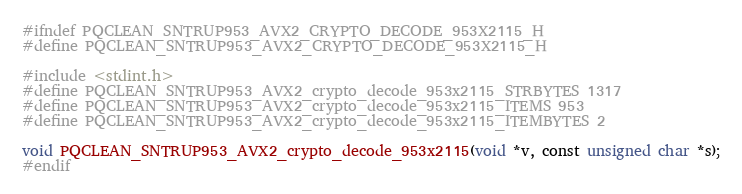Convert code to text. <code><loc_0><loc_0><loc_500><loc_500><_C_>#ifndef PQCLEAN_SNTRUP953_AVX2_CRYPTO_DECODE_953X2115_H
#define PQCLEAN_SNTRUP953_AVX2_CRYPTO_DECODE_953X2115_H

#include <stdint.h>
#define PQCLEAN_SNTRUP953_AVX2_crypto_decode_953x2115_STRBYTES 1317
#define PQCLEAN_SNTRUP953_AVX2_crypto_decode_953x2115_ITEMS 953
#define PQCLEAN_SNTRUP953_AVX2_crypto_decode_953x2115_ITEMBYTES 2

void PQCLEAN_SNTRUP953_AVX2_crypto_decode_953x2115(void *v, const unsigned char *s);
#endif
</code> 